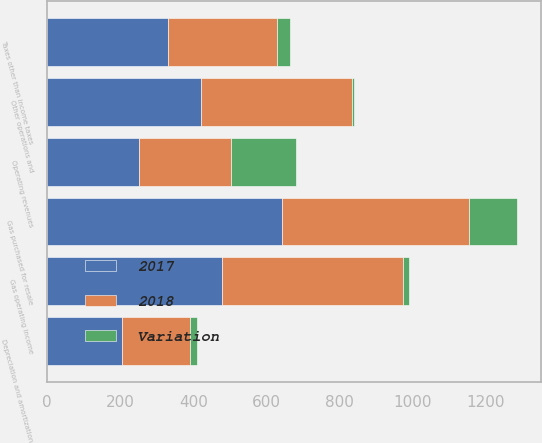Convert chart. <chart><loc_0><loc_0><loc_500><loc_500><stacked_bar_chart><ecel><fcel>Operating revenues<fcel>Gas purchased for resale<fcel>Other operations and<fcel>Depreciation and amortization<fcel>Taxes other than income taxes<fcel>Gas operating income<nl><fcel>2017<fcel>251.5<fcel>643<fcel>420<fcel>205<fcel>332<fcel>478<nl><fcel>2018<fcel>251.5<fcel>510<fcel>413<fcel>185<fcel>298<fcel>495<nl><fcel>Variation<fcel>177<fcel>133<fcel>7<fcel>20<fcel>34<fcel>17<nl></chart> 